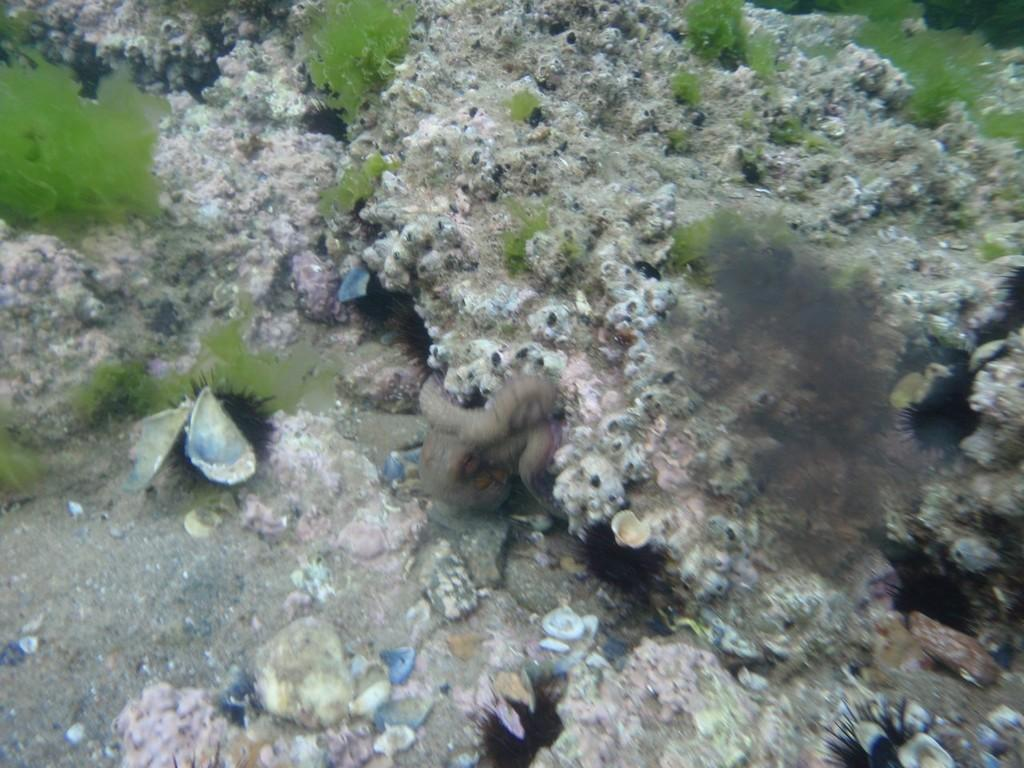What type of underwater environment is depicted in the image? There are coral reefs in the water in the image. What type of plant life can be seen in the image? There is algae visible in the image. What type of objects can be found in the image? There are shells in the image. What type of development is taking place in the image? There is no development taking place in the image; it depicts a natural underwater environment. 